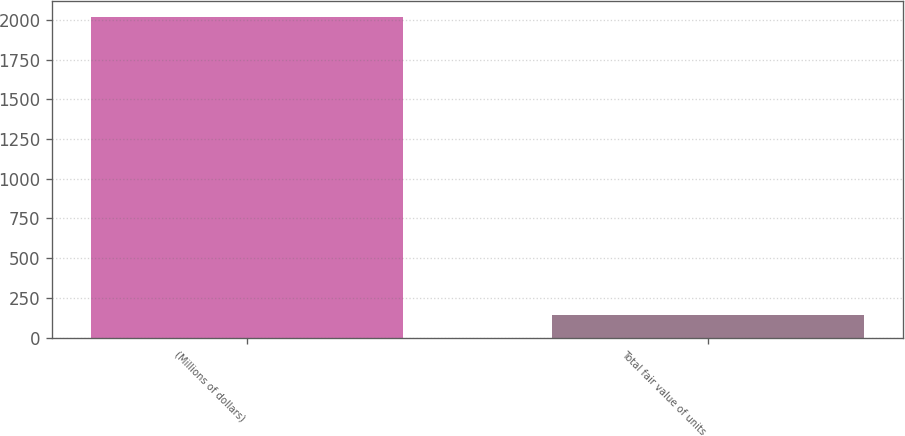Convert chart to OTSL. <chart><loc_0><loc_0><loc_500><loc_500><bar_chart><fcel>(Millions of dollars)<fcel>Total fair value of units<nl><fcel>2017<fcel>139<nl></chart> 